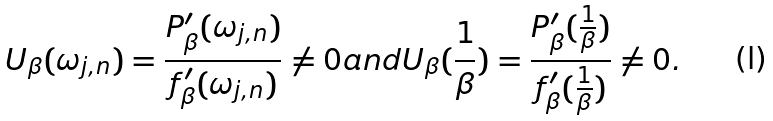<formula> <loc_0><loc_0><loc_500><loc_500>U _ { \beta } ( \omega _ { j , n } ) = \frac { P ^ { \prime } _ { \beta } ( \omega _ { j , n } ) } { f ^ { \prime } _ { \beta } ( \omega _ { j , n } ) } \neq 0 a n d U _ { \beta } ( \frac { 1 } { \beta } ) = \frac { P ^ { \prime } _ { \beta } ( \frac { 1 } { \beta } ) } { f ^ { \prime } _ { \beta } ( \frac { 1 } { \beta } ) } \neq 0 .</formula> 